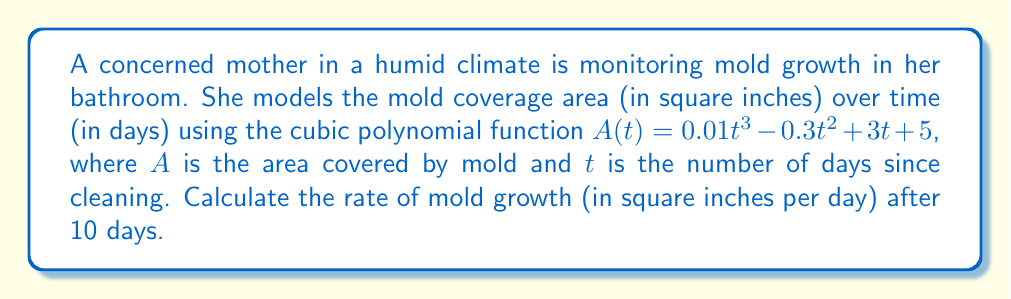What is the answer to this math problem? To find the rate of mold growth at a specific time, we need to calculate the derivative of the area function $A(t)$ and evaluate it at $t = 10$.

Step 1: Find the derivative of $A(t)$.
$$A(t) = 0.01t^3 - 0.3t^2 + 3t + 5$$
$$A'(t) = 0.03t^2 - 0.6t + 3$$

Step 2: Evaluate $A'(t)$ at $t = 10$.
$$A'(10) = 0.03(10)^2 - 0.6(10) + 3$$
$$A'(10) = 0.03(100) - 6 + 3$$
$$A'(10) = 3 - 6 + 3$$
$$A'(10) = 0$$

The rate of mold growth after 10 days is 0 square inches per day.
Answer: 0 sq in/day 